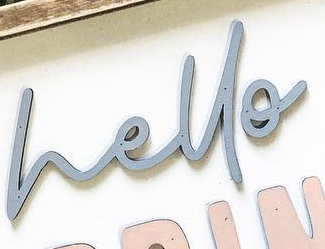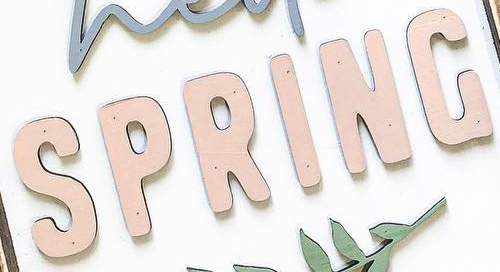Read the text from these images in sequence, separated by a semicolon. hello; SPRING 